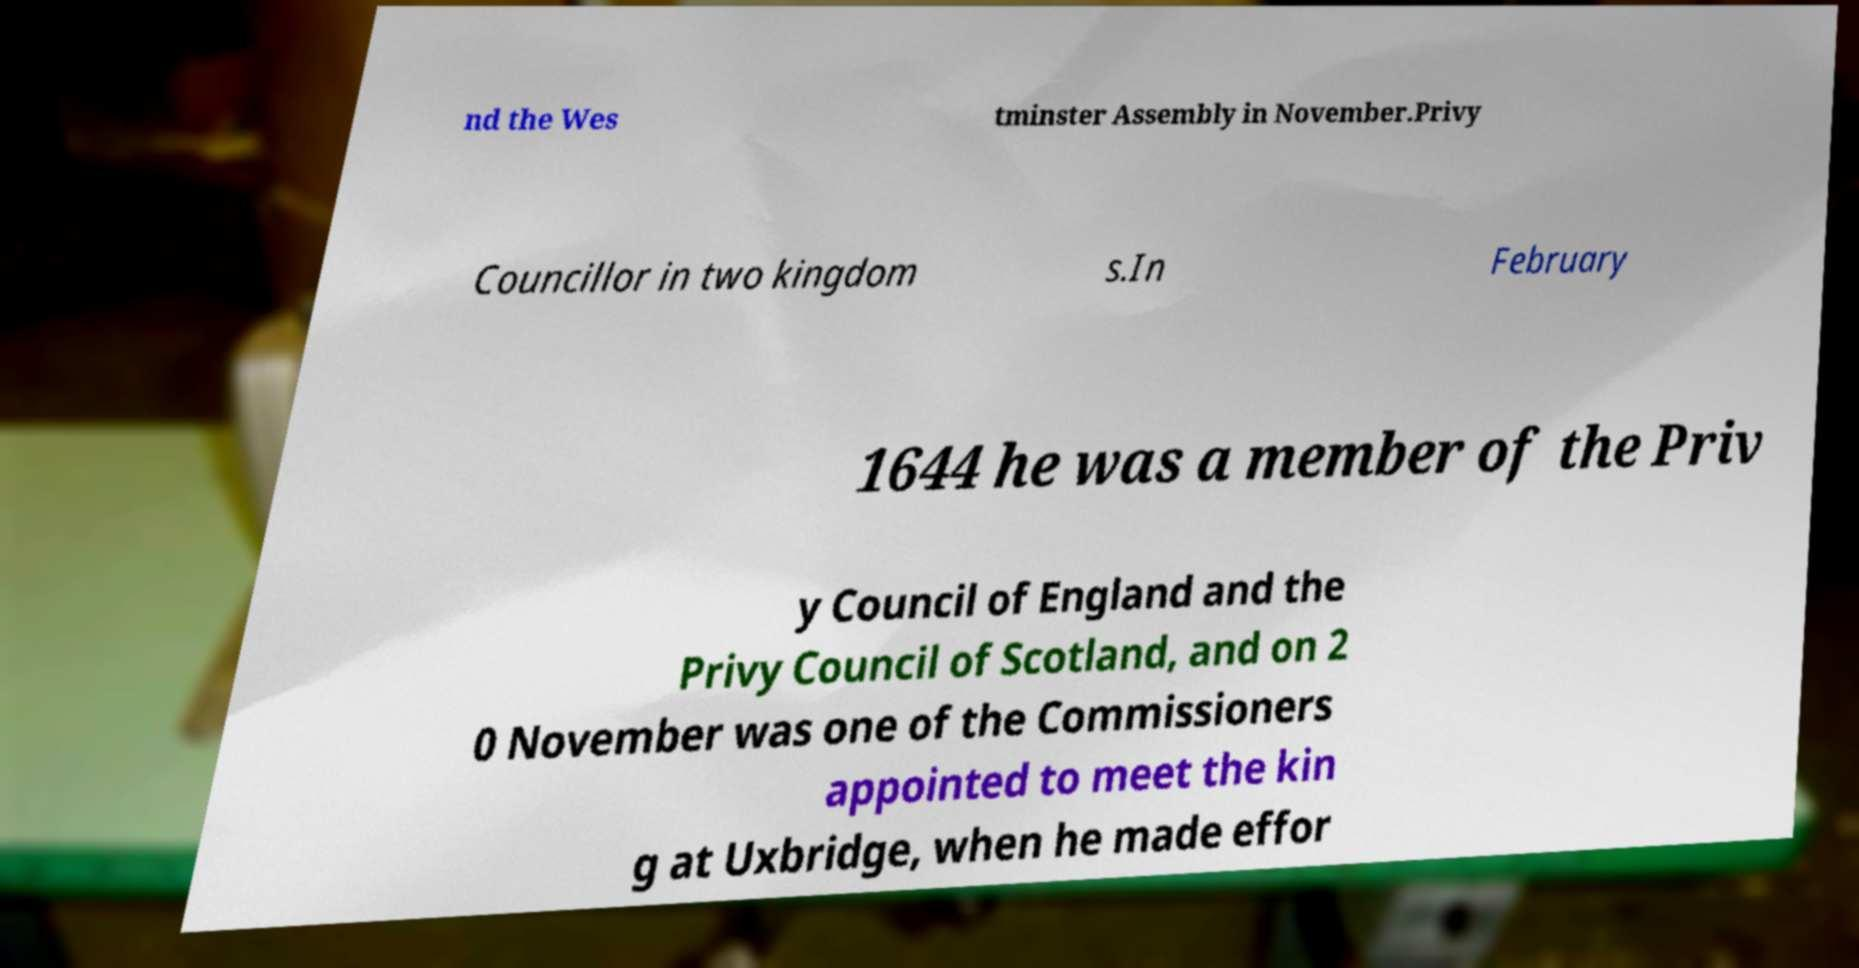I need the written content from this picture converted into text. Can you do that? nd the Wes tminster Assembly in November.Privy Councillor in two kingdom s.In February 1644 he was a member of the Priv y Council of England and the Privy Council of Scotland, and on 2 0 November was one of the Commissioners appointed to meet the kin g at Uxbridge, when he made effor 